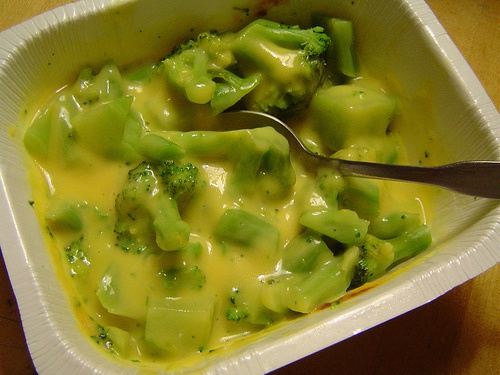Describe the objects in this image and their specific colors. I can see bowl in olive, tan, and black tones, broccoli in olive and black tones, broccoli in olive tones, broccoli in olive and darkgreen tones, and broccoli in olive tones in this image. 